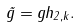Convert formula to latex. <formula><loc_0><loc_0><loc_500><loc_500>\tilde { g } = g h _ { 2 , k } .</formula> 